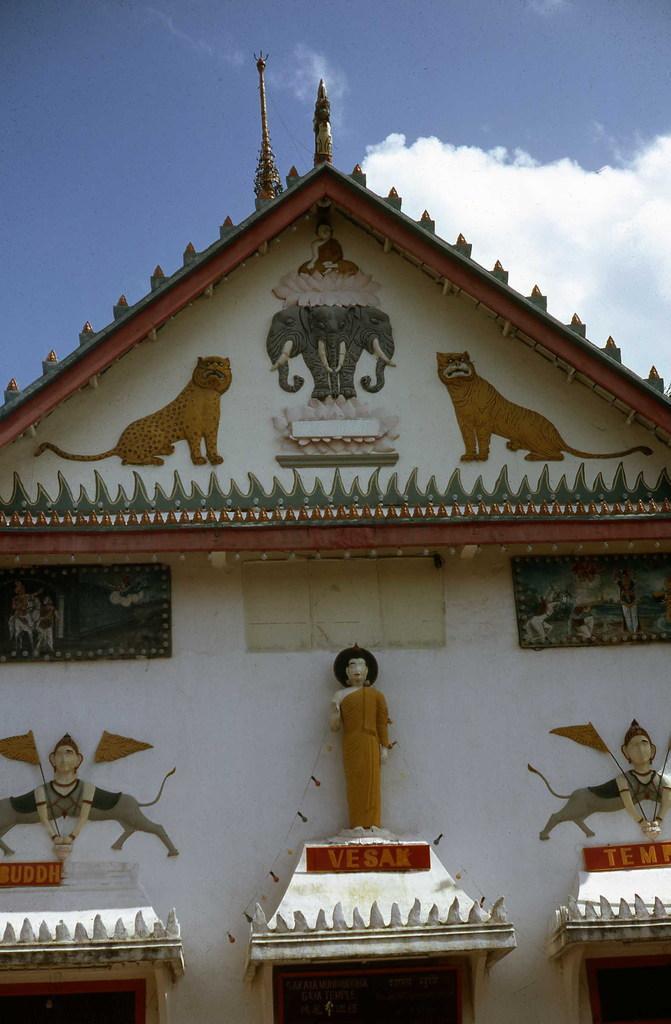Describe this image in one or two sentences. In this image, we can see a carving on the wall. Here we can see sculpture and few boards. Top of the image, there is a sky and poles. 